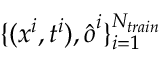<formula> <loc_0><loc_0><loc_500><loc_500>\{ ( x ^ { i } , t ^ { i } ) , \hat { o } ^ { i } \} _ { i = 1 } ^ { N _ { t r a i n } }</formula> 